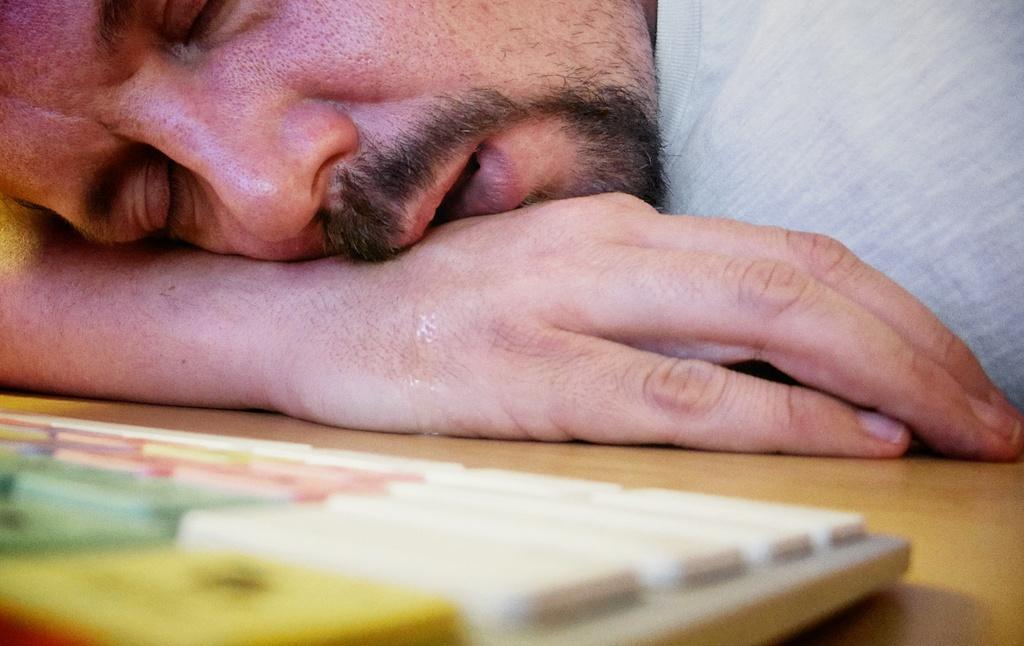In one or two sentences, can you explain what this image depicts? In the picture we can see a man sleeping on the desk keeping his hand under his head and in him we can see a keyboard on the desk. 